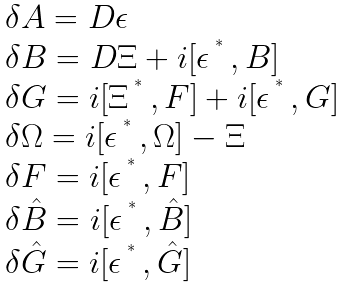<formula> <loc_0><loc_0><loc_500><loc_500>\begin{array} { l l } \delta { A } = D \epsilon \\ \delta B = D \Xi + i [ \epsilon \, ^ { ^ { * } } \, , B ] \\ \delta G = i [ \Xi \, ^ { ^ { * } } \, , F ] + i [ \epsilon \, ^ { ^ { * } } \, , G ] \\ \delta \Omega = i [ \epsilon \, ^ { ^ { * } } \, , \Omega ] - \Xi \\ \delta F = i [ \epsilon \, ^ { ^ { * } } \, , F ] \\ \delta { \hat { B } } = i [ \epsilon \, ^ { ^ { * } } \, , { \hat { B } } ] \\ \delta { \hat { G } } = i [ \epsilon \, ^ { ^ { * } } \, , \hat { G } ] \end{array}</formula> 